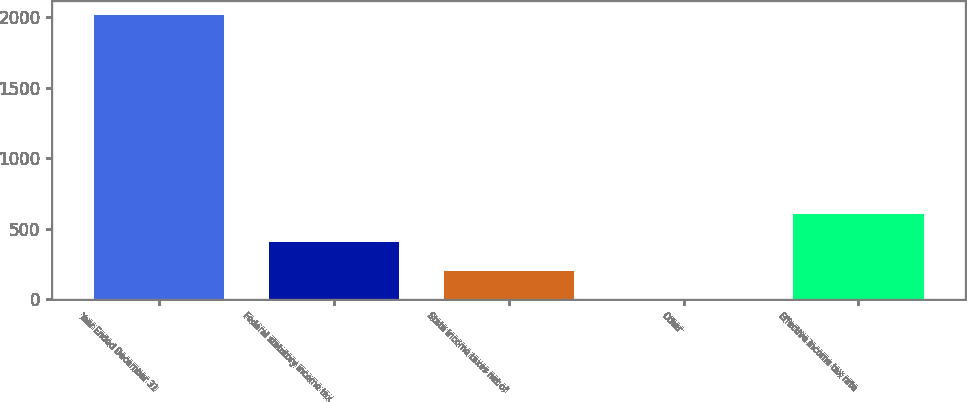<chart> <loc_0><loc_0><loc_500><loc_500><bar_chart><fcel>Year Ended December 31<fcel>Federal statutory income tax<fcel>State income taxes net of<fcel>Other<fcel>Effective income tax rate<nl><fcel>2011<fcel>402.52<fcel>201.46<fcel>0.4<fcel>603.58<nl></chart> 